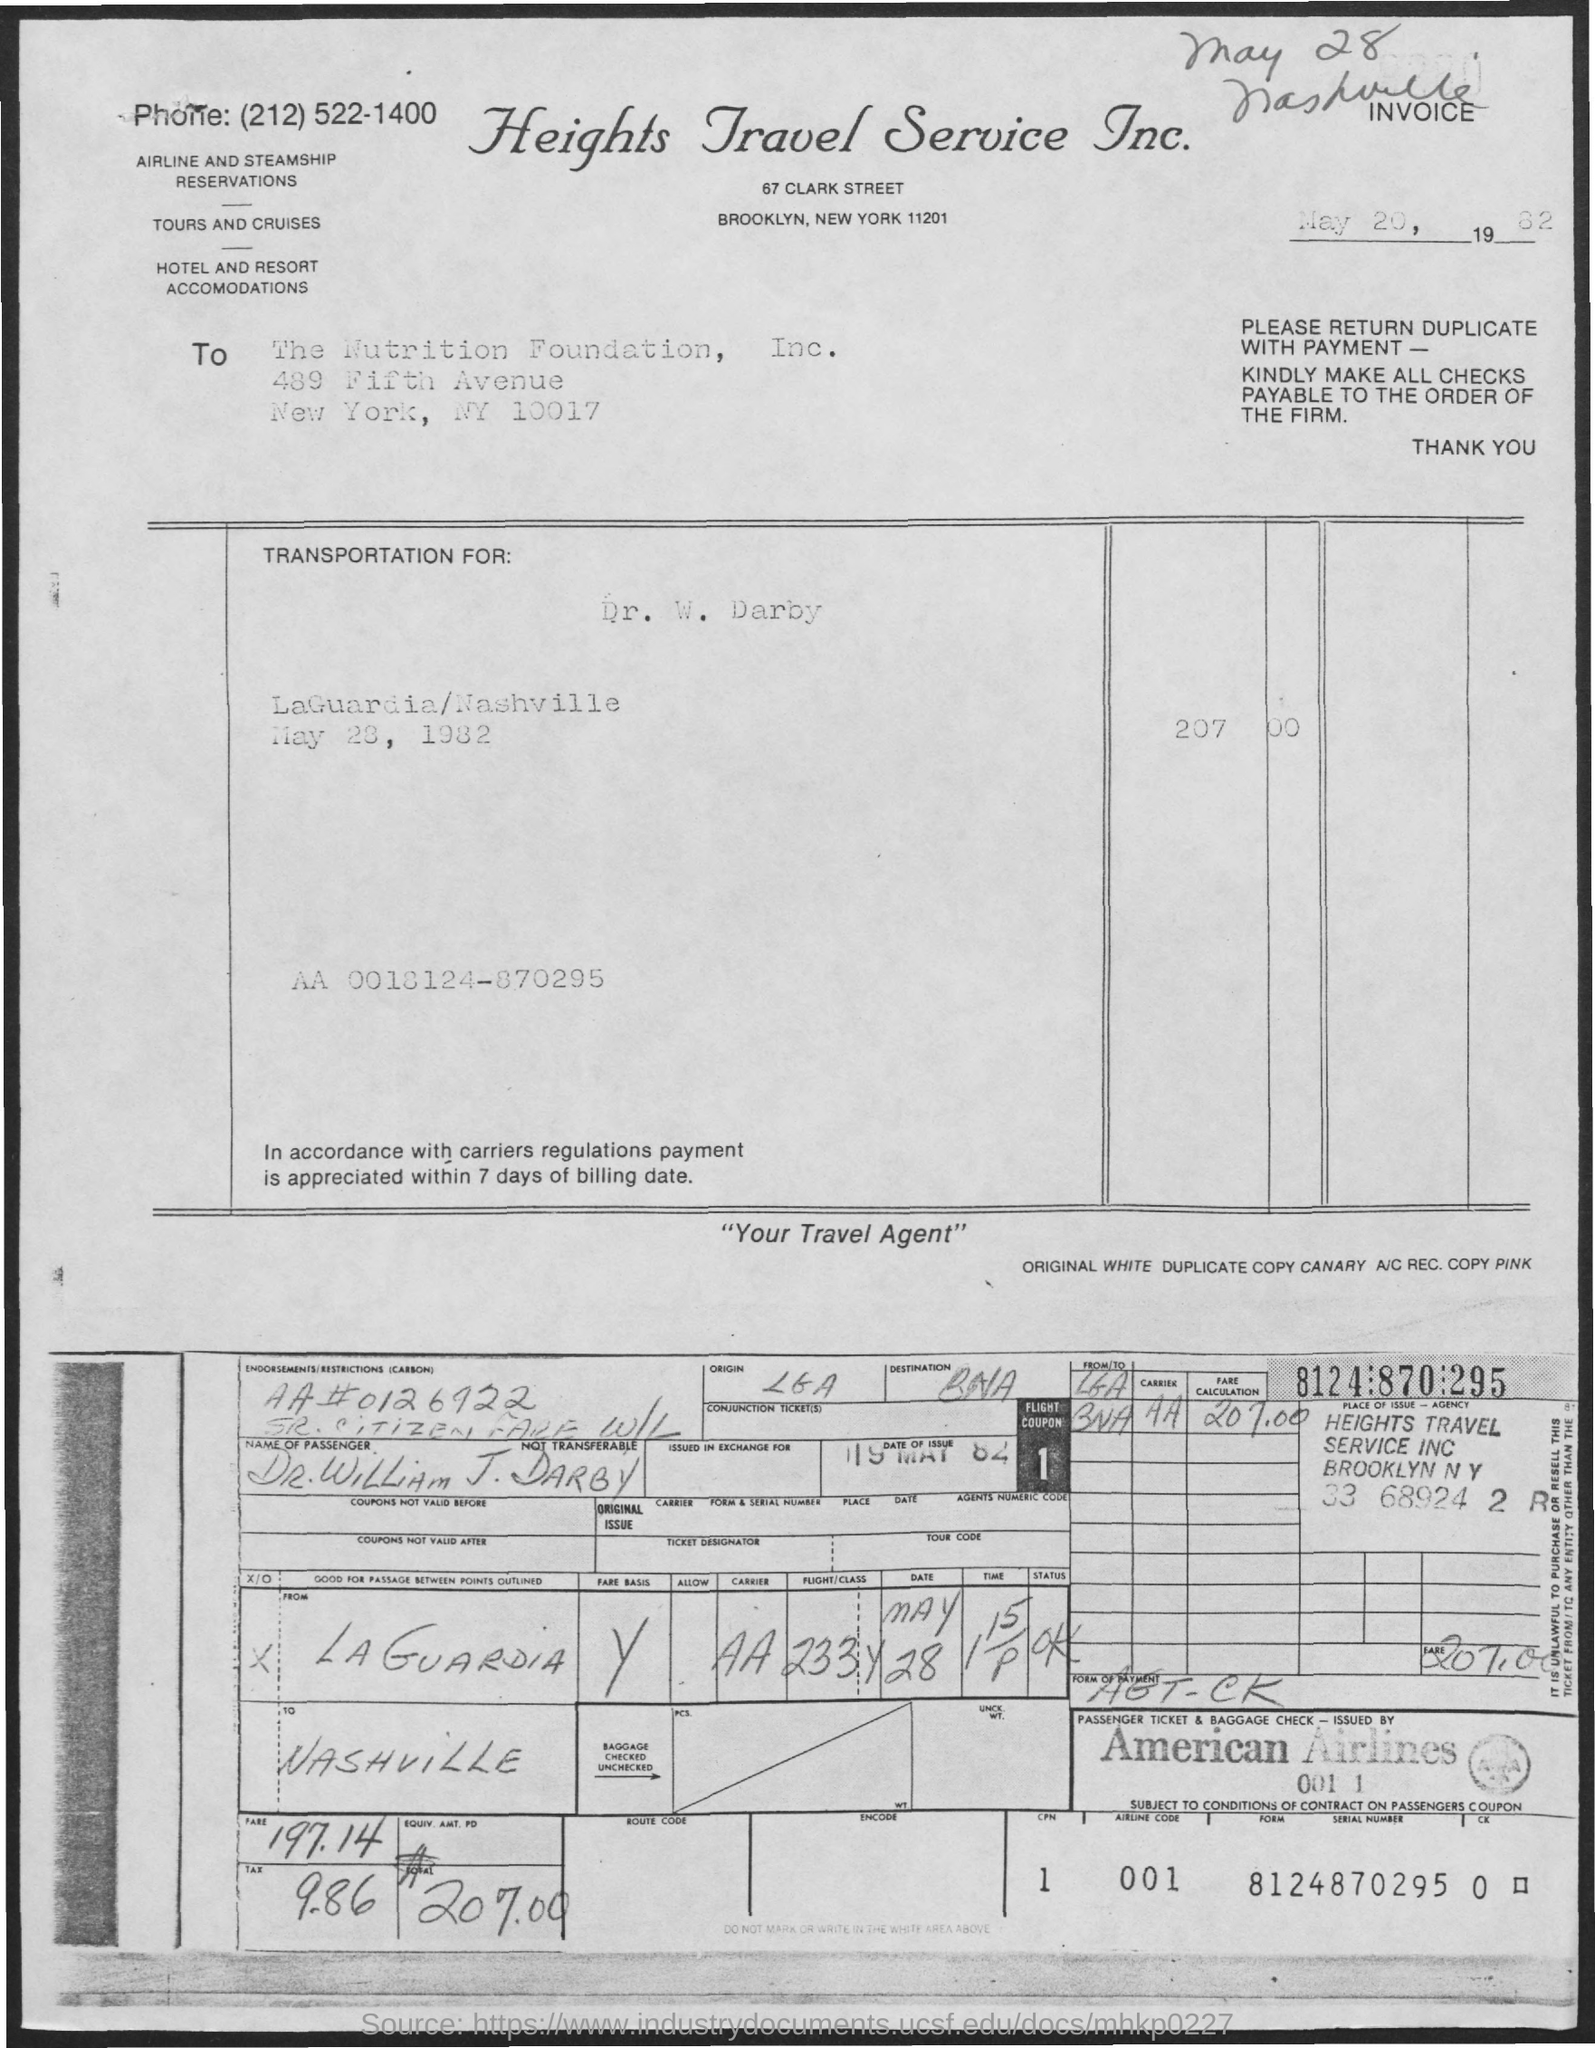Indicate a few pertinent items in this graphic. The flight coupon number is 1. The serial number is 8124870295. The title of the document is "Heights Travel Service Inc... The airline is called American Airlines. The airline code is a unique identifier for each airline, and the value '001' represents a specific airline. 